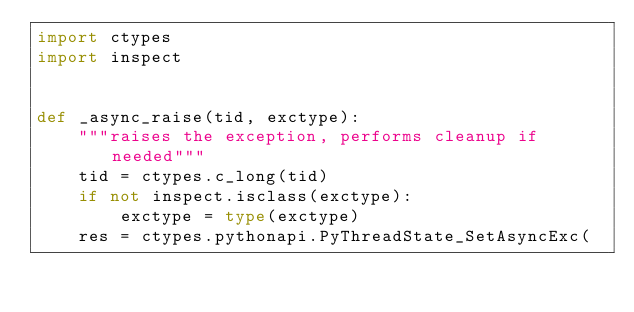<code> <loc_0><loc_0><loc_500><loc_500><_Python_>import ctypes
import inspect


def _async_raise(tid, exctype):
    """raises the exception, performs cleanup if needed"""
    tid = ctypes.c_long(tid)
    if not inspect.isclass(exctype):
        exctype = type(exctype)
    res = ctypes.pythonapi.PyThreadState_SetAsyncExc(</code> 